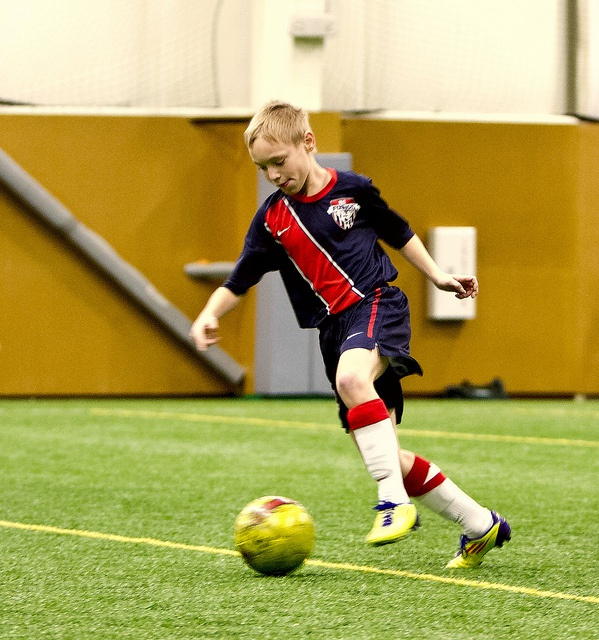Describe the objects in this image and their specific colors. I can see people in lightyellow, black, beige, tan, and brown tones and sports ball in lightyellow, olive, black, and khaki tones in this image. 